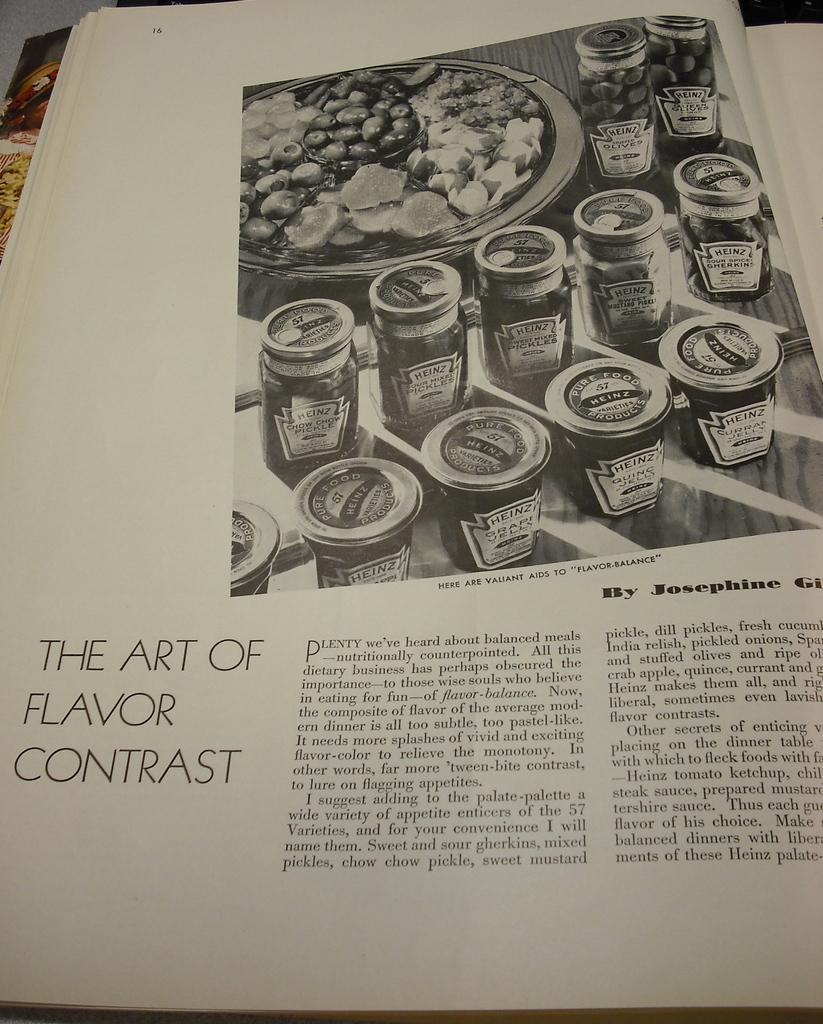Provide a one-sentence caption for the provided image. A book page that states the art of flavor contrast. 